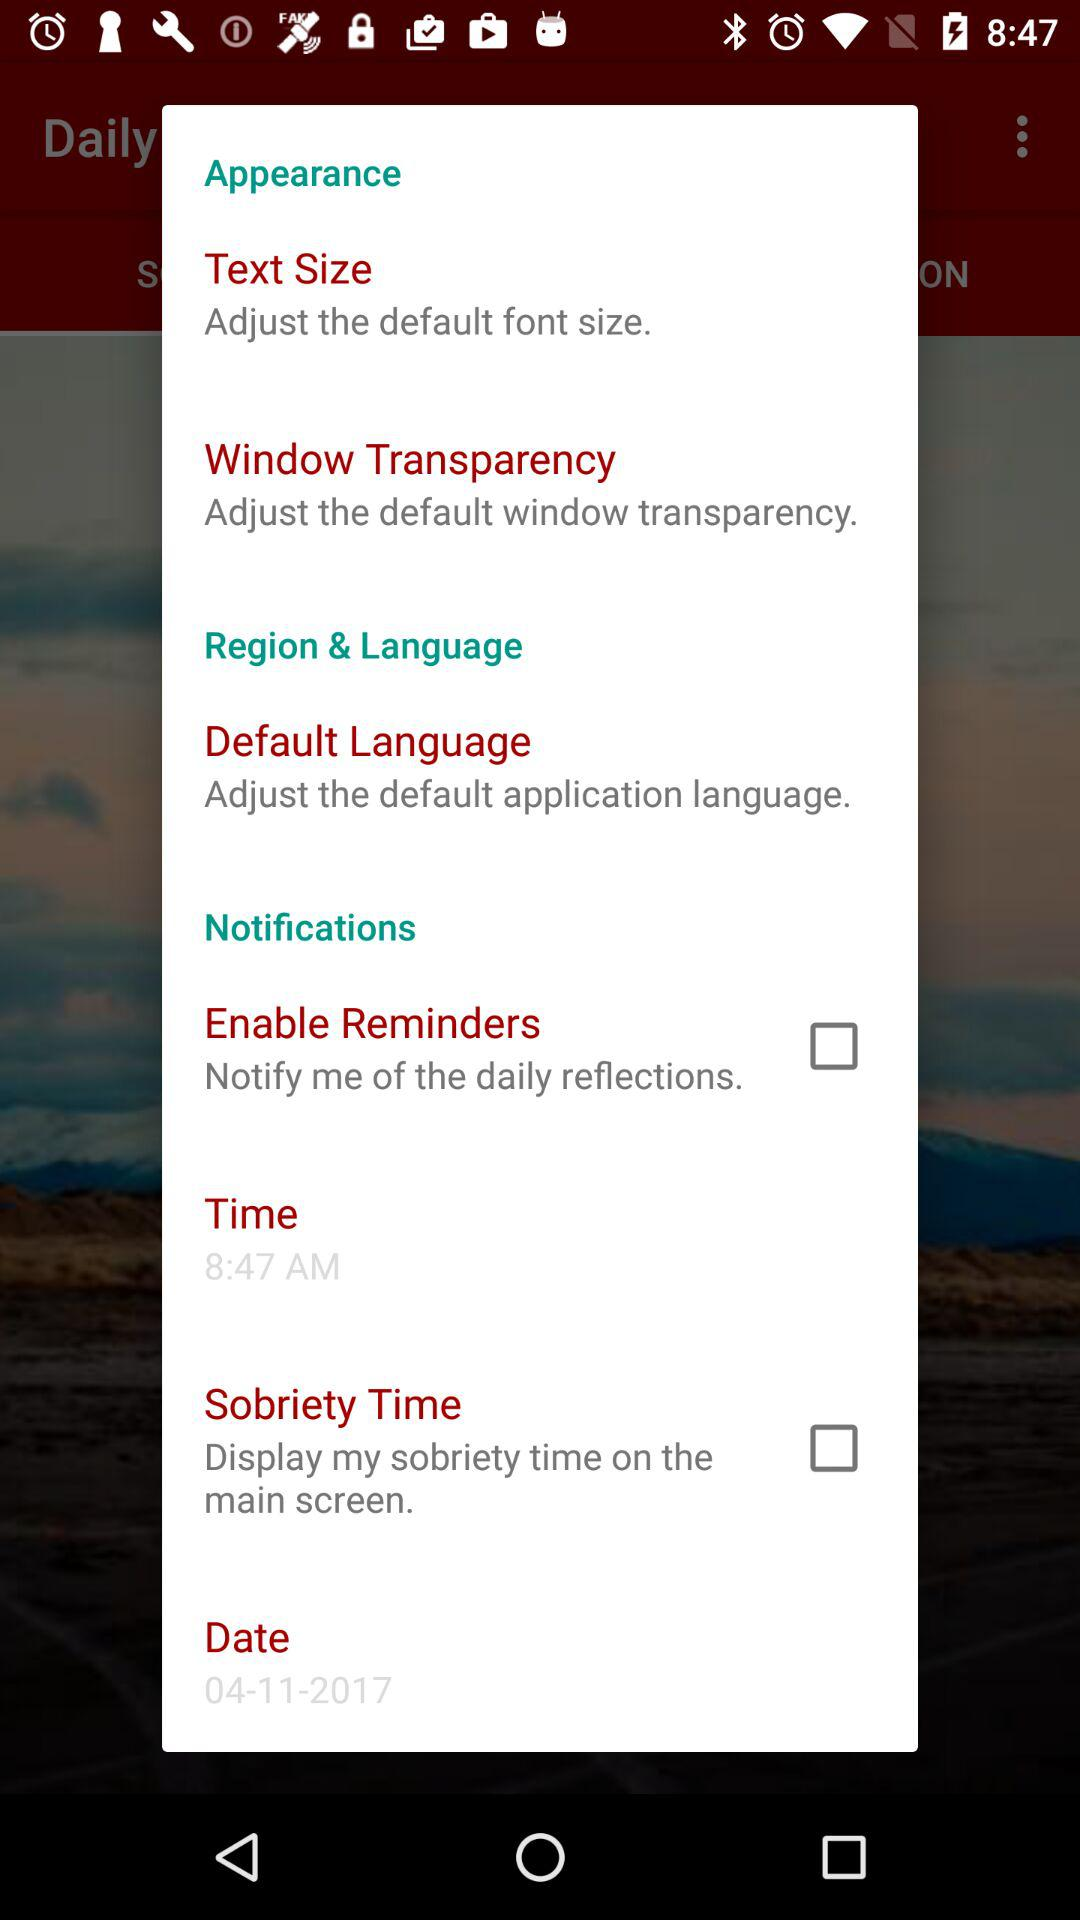What is the date? The date is April 11, 2017. 